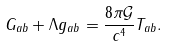Convert formula to latex. <formula><loc_0><loc_0><loc_500><loc_500>G _ { a b } + \Lambda g _ { a b } = \frac { 8 \pi \mathcal { G } } { c ^ { 4 } } T _ { a b } .</formula> 